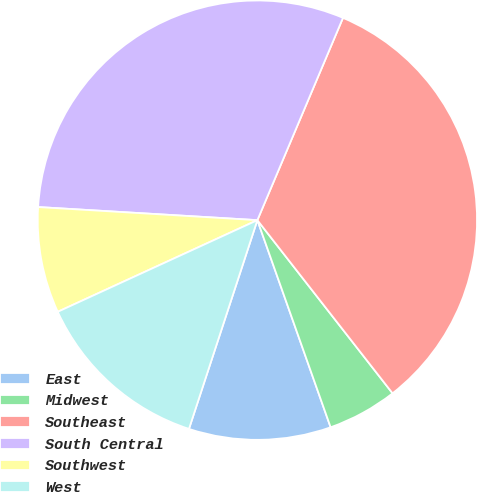<chart> <loc_0><loc_0><loc_500><loc_500><pie_chart><fcel>East<fcel>Midwest<fcel>Southeast<fcel>South Central<fcel>Southwest<fcel>West<nl><fcel>10.45%<fcel>5.14%<fcel>33.08%<fcel>30.42%<fcel>7.8%<fcel>13.11%<nl></chart> 